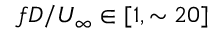Convert formula to latex. <formula><loc_0><loc_0><loc_500><loc_500>f D / U _ { \infty } \in [ 1 , \sim 2 0 ]</formula> 